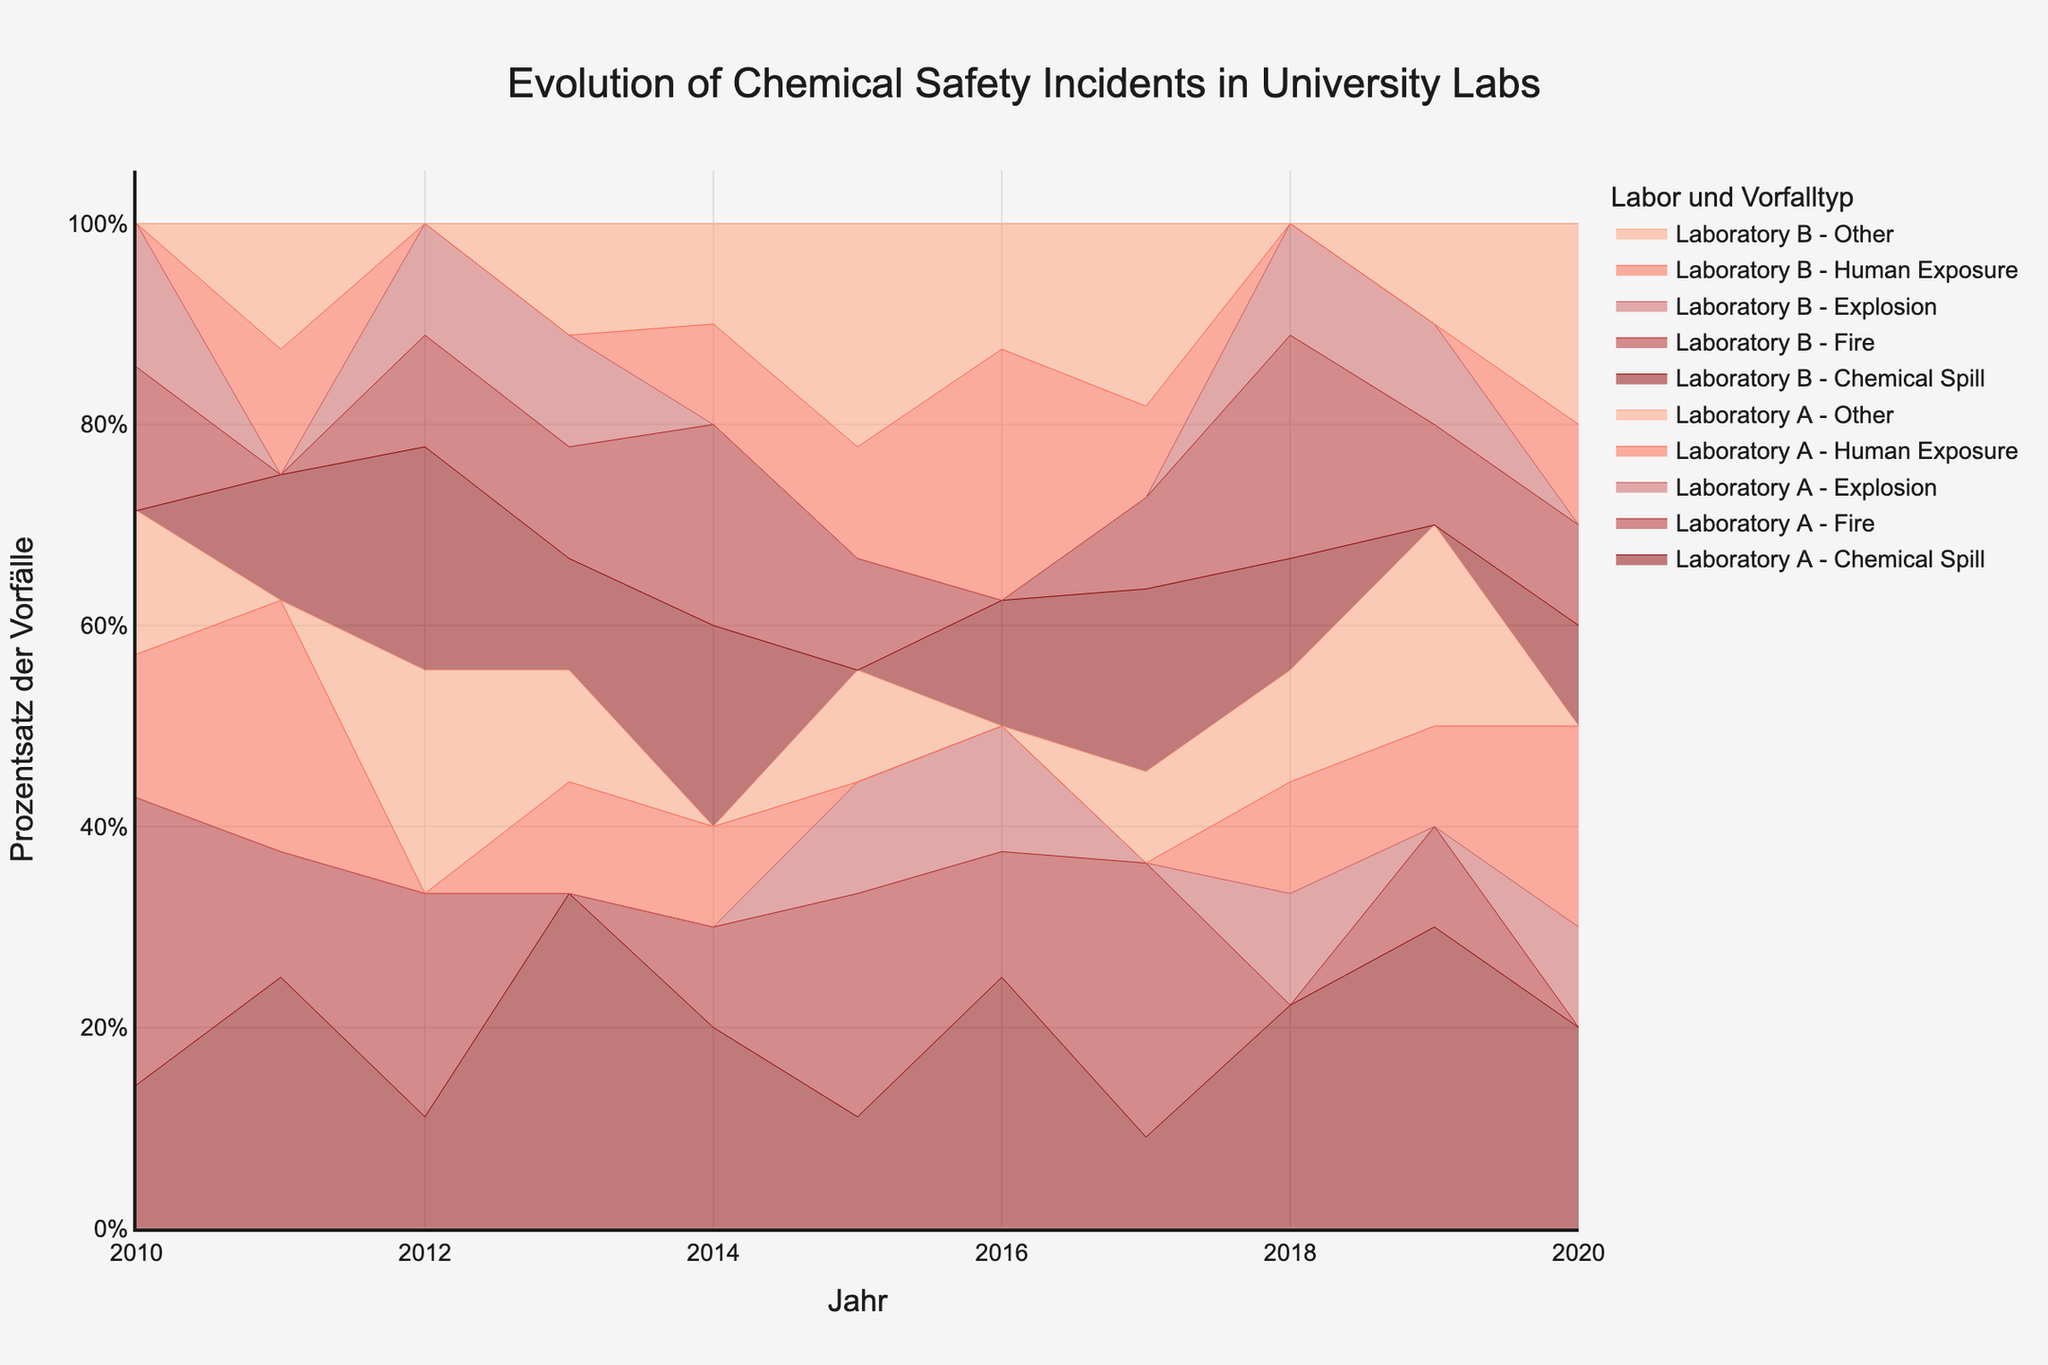What is the title of the chart? The title is usually located at the top of the chart. In this case, it's written in a larger and bold font for emphasis.
Answer: Evolution of Chemical Safety Incidents in University Labs What is represented on the x-axis of the chart? The x-axis typically represents the timeline of the data being shown. Here, it shows "Jahr", which is German for "Year".
Answer: Years What is the y-axis labeled as? The y-axis title is usually descriptive of what the values on this axis represent. In this chart, it's labeled as "Prozentsatz der Vorfälle", which translates from German to "Percentage of Incidents".
Answer: Percentage of Incidents Which laboratory had the highest number of "Fire" incidents in 2017? Look at the color and label for "Fire" on the step area chart for 2017. Check the height for both Laboratory A and Laboratory B and compare.
Answer: Laboratory A Across all years, which type of incident had the greatest cumulative percentage for Laboratory B? For this, calculate the cumulative percentage for each incident type over all years for Laboratory B and compare them.
Answer: Chemical Spill Compare the trend of "Human Exposure" incidents between Laboratory A and Laboratory B from 2015 to 2020. Look at the segments corresponding to "Human Exposure" incidents for both laboratories between 2015 and 2020. Compare their heights and slopes to identify trends.
Answer: Laboratory A shows a general decrease, while Laboratory B shows fluctuations but no clear trend In which year did Laboratory A have the highest total percentage of all incidents combined? Sum the percentages of all incident types for Laboratory A for each year and identify the year with the highest total.
Answer: 2019 Did any incident type in Laboratory B show a consistent increase from 2010 to 2020? Examine the step areas for each incident type in Laboratory B across the years. "Consistent increase" means the percentage should steadily rise each year.
Answer: No Which type of incident saw the highest increase in percentage for Laboratory A from 2019 to 2020? Compare the step heights of each incident type for the years 2019 and 2020 for Laboratory A to see which had the largest increase.
Answer: Human Exposure How do the "Explosion" incidents compare between Laboratory A and Laboratory B over the decade? Track the "Explosion" incident step areas for both labs over the 10 years to determine differences in trends and quantities.
Answer: Laboratory B generally had more explosions than Laboratory A 